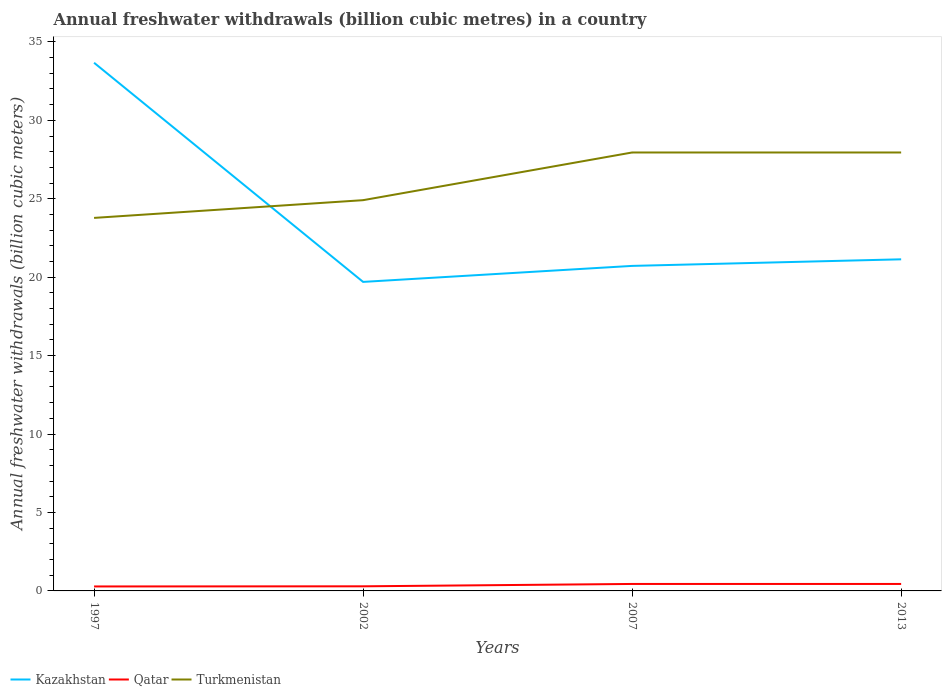How many different coloured lines are there?
Keep it short and to the point. 3. Is the number of lines equal to the number of legend labels?
Ensure brevity in your answer.  Yes. Across all years, what is the maximum annual freshwater withdrawals in Kazakhstan?
Provide a short and direct response. 19.7. What is the total annual freshwater withdrawals in Qatar in the graph?
Your answer should be very brief. -0.01. What is the difference between the highest and the second highest annual freshwater withdrawals in Turkmenistan?
Provide a succinct answer. 4.17. Is the annual freshwater withdrawals in Kazakhstan strictly greater than the annual freshwater withdrawals in Turkmenistan over the years?
Give a very brief answer. No. How many years are there in the graph?
Give a very brief answer. 4. What is the difference between two consecutive major ticks on the Y-axis?
Your answer should be compact. 5. How many legend labels are there?
Offer a very short reply. 3. What is the title of the graph?
Offer a terse response. Annual freshwater withdrawals (billion cubic metres) in a country. Does "Mauritius" appear as one of the legend labels in the graph?
Provide a short and direct response. No. What is the label or title of the Y-axis?
Ensure brevity in your answer.  Annual freshwater withdrawals (billion cubic meters). What is the Annual freshwater withdrawals (billion cubic meters) in Kazakhstan in 1997?
Ensure brevity in your answer.  33.67. What is the Annual freshwater withdrawals (billion cubic meters) in Qatar in 1997?
Offer a very short reply. 0.28. What is the Annual freshwater withdrawals (billion cubic meters) of Turkmenistan in 1997?
Offer a terse response. 23.78. What is the Annual freshwater withdrawals (billion cubic meters) in Kazakhstan in 2002?
Your answer should be very brief. 19.7. What is the Annual freshwater withdrawals (billion cubic meters) in Qatar in 2002?
Your answer should be very brief. 0.29. What is the Annual freshwater withdrawals (billion cubic meters) of Turkmenistan in 2002?
Your answer should be compact. 24.91. What is the Annual freshwater withdrawals (billion cubic meters) of Kazakhstan in 2007?
Offer a terse response. 20.72. What is the Annual freshwater withdrawals (billion cubic meters) in Qatar in 2007?
Provide a short and direct response. 0.44. What is the Annual freshwater withdrawals (billion cubic meters) in Turkmenistan in 2007?
Make the answer very short. 27.95. What is the Annual freshwater withdrawals (billion cubic meters) in Kazakhstan in 2013?
Keep it short and to the point. 21.14. What is the Annual freshwater withdrawals (billion cubic meters) in Qatar in 2013?
Ensure brevity in your answer.  0.44. What is the Annual freshwater withdrawals (billion cubic meters) of Turkmenistan in 2013?
Keep it short and to the point. 27.95. Across all years, what is the maximum Annual freshwater withdrawals (billion cubic meters) in Kazakhstan?
Make the answer very short. 33.67. Across all years, what is the maximum Annual freshwater withdrawals (billion cubic meters) of Qatar?
Ensure brevity in your answer.  0.44. Across all years, what is the maximum Annual freshwater withdrawals (billion cubic meters) of Turkmenistan?
Ensure brevity in your answer.  27.95. Across all years, what is the minimum Annual freshwater withdrawals (billion cubic meters) in Qatar?
Keep it short and to the point. 0.28. Across all years, what is the minimum Annual freshwater withdrawals (billion cubic meters) of Turkmenistan?
Provide a short and direct response. 23.78. What is the total Annual freshwater withdrawals (billion cubic meters) in Kazakhstan in the graph?
Provide a short and direct response. 95.23. What is the total Annual freshwater withdrawals (billion cubic meters) of Qatar in the graph?
Offer a very short reply. 1.47. What is the total Annual freshwater withdrawals (billion cubic meters) in Turkmenistan in the graph?
Provide a short and direct response. 104.59. What is the difference between the Annual freshwater withdrawals (billion cubic meters) of Kazakhstan in 1997 and that in 2002?
Make the answer very short. 13.97. What is the difference between the Annual freshwater withdrawals (billion cubic meters) in Qatar in 1997 and that in 2002?
Offer a very short reply. -0.01. What is the difference between the Annual freshwater withdrawals (billion cubic meters) of Turkmenistan in 1997 and that in 2002?
Provide a short and direct response. -1.13. What is the difference between the Annual freshwater withdrawals (billion cubic meters) in Kazakhstan in 1997 and that in 2007?
Offer a very short reply. 12.95. What is the difference between the Annual freshwater withdrawals (billion cubic meters) of Qatar in 1997 and that in 2007?
Keep it short and to the point. -0.16. What is the difference between the Annual freshwater withdrawals (billion cubic meters) in Turkmenistan in 1997 and that in 2007?
Keep it short and to the point. -4.17. What is the difference between the Annual freshwater withdrawals (billion cubic meters) in Kazakhstan in 1997 and that in 2013?
Ensure brevity in your answer.  12.53. What is the difference between the Annual freshwater withdrawals (billion cubic meters) in Qatar in 1997 and that in 2013?
Your answer should be very brief. -0.16. What is the difference between the Annual freshwater withdrawals (billion cubic meters) in Turkmenistan in 1997 and that in 2013?
Keep it short and to the point. -4.17. What is the difference between the Annual freshwater withdrawals (billion cubic meters) in Kazakhstan in 2002 and that in 2007?
Provide a short and direct response. -1.02. What is the difference between the Annual freshwater withdrawals (billion cubic meters) of Qatar in 2002 and that in 2007?
Give a very brief answer. -0.15. What is the difference between the Annual freshwater withdrawals (billion cubic meters) in Turkmenistan in 2002 and that in 2007?
Provide a short and direct response. -3.04. What is the difference between the Annual freshwater withdrawals (billion cubic meters) of Kazakhstan in 2002 and that in 2013?
Keep it short and to the point. -1.44. What is the difference between the Annual freshwater withdrawals (billion cubic meters) of Qatar in 2002 and that in 2013?
Offer a terse response. -0.15. What is the difference between the Annual freshwater withdrawals (billion cubic meters) of Turkmenistan in 2002 and that in 2013?
Provide a short and direct response. -3.04. What is the difference between the Annual freshwater withdrawals (billion cubic meters) of Kazakhstan in 2007 and that in 2013?
Provide a succinct answer. -0.42. What is the difference between the Annual freshwater withdrawals (billion cubic meters) in Qatar in 2007 and that in 2013?
Give a very brief answer. 0. What is the difference between the Annual freshwater withdrawals (billion cubic meters) of Kazakhstan in 1997 and the Annual freshwater withdrawals (billion cubic meters) of Qatar in 2002?
Offer a very short reply. 33.38. What is the difference between the Annual freshwater withdrawals (billion cubic meters) in Kazakhstan in 1997 and the Annual freshwater withdrawals (billion cubic meters) in Turkmenistan in 2002?
Offer a terse response. 8.76. What is the difference between the Annual freshwater withdrawals (billion cubic meters) in Qatar in 1997 and the Annual freshwater withdrawals (billion cubic meters) in Turkmenistan in 2002?
Provide a short and direct response. -24.63. What is the difference between the Annual freshwater withdrawals (billion cubic meters) of Kazakhstan in 1997 and the Annual freshwater withdrawals (billion cubic meters) of Qatar in 2007?
Make the answer very short. 33.23. What is the difference between the Annual freshwater withdrawals (billion cubic meters) in Kazakhstan in 1997 and the Annual freshwater withdrawals (billion cubic meters) in Turkmenistan in 2007?
Offer a terse response. 5.72. What is the difference between the Annual freshwater withdrawals (billion cubic meters) in Qatar in 1997 and the Annual freshwater withdrawals (billion cubic meters) in Turkmenistan in 2007?
Give a very brief answer. -27.67. What is the difference between the Annual freshwater withdrawals (billion cubic meters) in Kazakhstan in 1997 and the Annual freshwater withdrawals (billion cubic meters) in Qatar in 2013?
Give a very brief answer. 33.23. What is the difference between the Annual freshwater withdrawals (billion cubic meters) in Kazakhstan in 1997 and the Annual freshwater withdrawals (billion cubic meters) in Turkmenistan in 2013?
Your response must be concise. 5.72. What is the difference between the Annual freshwater withdrawals (billion cubic meters) in Qatar in 1997 and the Annual freshwater withdrawals (billion cubic meters) in Turkmenistan in 2013?
Your response must be concise. -27.67. What is the difference between the Annual freshwater withdrawals (billion cubic meters) of Kazakhstan in 2002 and the Annual freshwater withdrawals (billion cubic meters) of Qatar in 2007?
Offer a terse response. 19.26. What is the difference between the Annual freshwater withdrawals (billion cubic meters) in Kazakhstan in 2002 and the Annual freshwater withdrawals (billion cubic meters) in Turkmenistan in 2007?
Provide a succinct answer. -8.25. What is the difference between the Annual freshwater withdrawals (billion cubic meters) of Qatar in 2002 and the Annual freshwater withdrawals (billion cubic meters) of Turkmenistan in 2007?
Offer a very short reply. -27.66. What is the difference between the Annual freshwater withdrawals (billion cubic meters) in Kazakhstan in 2002 and the Annual freshwater withdrawals (billion cubic meters) in Qatar in 2013?
Offer a terse response. 19.26. What is the difference between the Annual freshwater withdrawals (billion cubic meters) of Kazakhstan in 2002 and the Annual freshwater withdrawals (billion cubic meters) of Turkmenistan in 2013?
Provide a succinct answer. -8.25. What is the difference between the Annual freshwater withdrawals (billion cubic meters) of Qatar in 2002 and the Annual freshwater withdrawals (billion cubic meters) of Turkmenistan in 2013?
Ensure brevity in your answer.  -27.66. What is the difference between the Annual freshwater withdrawals (billion cubic meters) of Kazakhstan in 2007 and the Annual freshwater withdrawals (billion cubic meters) of Qatar in 2013?
Provide a short and direct response. 20.28. What is the difference between the Annual freshwater withdrawals (billion cubic meters) of Kazakhstan in 2007 and the Annual freshwater withdrawals (billion cubic meters) of Turkmenistan in 2013?
Ensure brevity in your answer.  -7.23. What is the difference between the Annual freshwater withdrawals (billion cubic meters) in Qatar in 2007 and the Annual freshwater withdrawals (billion cubic meters) in Turkmenistan in 2013?
Ensure brevity in your answer.  -27.51. What is the average Annual freshwater withdrawals (billion cubic meters) in Kazakhstan per year?
Your answer should be very brief. 23.81. What is the average Annual freshwater withdrawals (billion cubic meters) of Qatar per year?
Provide a short and direct response. 0.37. What is the average Annual freshwater withdrawals (billion cubic meters) of Turkmenistan per year?
Keep it short and to the point. 26.15. In the year 1997, what is the difference between the Annual freshwater withdrawals (billion cubic meters) in Kazakhstan and Annual freshwater withdrawals (billion cubic meters) in Qatar?
Offer a terse response. 33.39. In the year 1997, what is the difference between the Annual freshwater withdrawals (billion cubic meters) in Kazakhstan and Annual freshwater withdrawals (billion cubic meters) in Turkmenistan?
Your response must be concise. 9.89. In the year 1997, what is the difference between the Annual freshwater withdrawals (billion cubic meters) of Qatar and Annual freshwater withdrawals (billion cubic meters) of Turkmenistan?
Your answer should be compact. -23.5. In the year 2002, what is the difference between the Annual freshwater withdrawals (billion cubic meters) in Kazakhstan and Annual freshwater withdrawals (billion cubic meters) in Qatar?
Your answer should be compact. 19.41. In the year 2002, what is the difference between the Annual freshwater withdrawals (billion cubic meters) of Kazakhstan and Annual freshwater withdrawals (billion cubic meters) of Turkmenistan?
Keep it short and to the point. -5.21. In the year 2002, what is the difference between the Annual freshwater withdrawals (billion cubic meters) of Qatar and Annual freshwater withdrawals (billion cubic meters) of Turkmenistan?
Give a very brief answer. -24.62. In the year 2007, what is the difference between the Annual freshwater withdrawals (billion cubic meters) of Kazakhstan and Annual freshwater withdrawals (billion cubic meters) of Qatar?
Your response must be concise. 20.28. In the year 2007, what is the difference between the Annual freshwater withdrawals (billion cubic meters) in Kazakhstan and Annual freshwater withdrawals (billion cubic meters) in Turkmenistan?
Offer a very short reply. -7.23. In the year 2007, what is the difference between the Annual freshwater withdrawals (billion cubic meters) of Qatar and Annual freshwater withdrawals (billion cubic meters) of Turkmenistan?
Provide a succinct answer. -27.51. In the year 2013, what is the difference between the Annual freshwater withdrawals (billion cubic meters) in Kazakhstan and Annual freshwater withdrawals (billion cubic meters) in Qatar?
Give a very brief answer. 20.7. In the year 2013, what is the difference between the Annual freshwater withdrawals (billion cubic meters) of Kazakhstan and Annual freshwater withdrawals (billion cubic meters) of Turkmenistan?
Your answer should be compact. -6.81. In the year 2013, what is the difference between the Annual freshwater withdrawals (billion cubic meters) of Qatar and Annual freshwater withdrawals (billion cubic meters) of Turkmenistan?
Provide a succinct answer. -27.51. What is the ratio of the Annual freshwater withdrawals (billion cubic meters) in Kazakhstan in 1997 to that in 2002?
Offer a very short reply. 1.71. What is the ratio of the Annual freshwater withdrawals (billion cubic meters) in Qatar in 1997 to that in 2002?
Provide a succinct answer. 0.97. What is the ratio of the Annual freshwater withdrawals (billion cubic meters) in Turkmenistan in 1997 to that in 2002?
Give a very brief answer. 0.95. What is the ratio of the Annual freshwater withdrawals (billion cubic meters) in Kazakhstan in 1997 to that in 2007?
Your answer should be very brief. 1.62. What is the ratio of the Annual freshwater withdrawals (billion cubic meters) of Qatar in 1997 to that in 2007?
Give a very brief answer. 0.64. What is the ratio of the Annual freshwater withdrawals (billion cubic meters) in Turkmenistan in 1997 to that in 2007?
Offer a very short reply. 0.85. What is the ratio of the Annual freshwater withdrawals (billion cubic meters) in Kazakhstan in 1997 to that in 2013?
Give a very brief answer. 1.59. What is the ratio of the Annual freshwater withdrawals (billion cubic meters) in Qatar in 1997 to that in 2013?
Make the answer very short. 0.64. What is the ratio of the Annual freshwater withdrawals (billion cubic meters) of Turkmenistan in 1997 to that in 2013?
Your answer should be compact. 0.85. What is the ratio of the Annual freshwater withdrawals (billion cubic meters) of Kazakhstan in 2002 to that in 2007?
Make the answer very short. 0.95. What is the ratio of the Annual freshwater withdrawals (billion cubic meters) in Qatar in 2002 to that in 2007?
Your response must be concise. 0.66. What is the ratio of the Annual freshwater withdrawals (billion cubic meters) in Turkmenistan in 2002 to that in 2007?
Provide a succinct answer. 0.89. What is the ratio of the Annual freshwater withdrawals (billion cubic meters) of Kazakhstan in 2002 to that in 2013?
Your answer should be very brief. 0.93. What is the ratio of the Annual freshwater withdrawals (billion cubic meters) of Qatar in 2002 to that in 2013?
Make the answer very short. 0.66. What is the ratio of the Annual freshwater withdrawals (billion cubic meters) in Turkmenistan in 2002 to that in 2013?
Your answer should be very brief. 0.89. What is the ratio of the Annual freshwater withdrawals (billion cubic meters) of Kazakhstan in 2007 to that in 2013?
Ensure brevity in your answer.  0.98. What is the ratio of the Annual freshwater withdrawals (billion cubic meters) in Qatar in 2007 to that in 2013?
Keep it short and to the point. 1. What is the ratio of the Annual freshwater withdrawals (billion cubic meters) in Turkmenistan in 2007 to that in 2013?
Ensure brevity in your answer.  1. What is the difference between the highest and the second highest Annual freshwater withdrawals (billion cubic meters) in Kazakhstan?
Offer a very short reply. 12.53. What is the difference between the highest and the second highest Annual freshwater withdrawals (billion cubic meters) of Turkmenistan?
Provide a succinct answer. 0. What is the difference between the highest and the lowest Annual freshwater withdrawals (billion cubic meters) of Kazakhstan?
Offer a terse response. 13.97. What is the difference between the highest and the lowest Annual freshwater withdrawals (billion cubic meters) in Qatar?
Provide a short and direct response. 0.16. What is the difference between the highest and the lowest Annual freshwater withdrawals (billion cubic meters) in Turkmenistan?
Your answer should be compact. 4.17. 